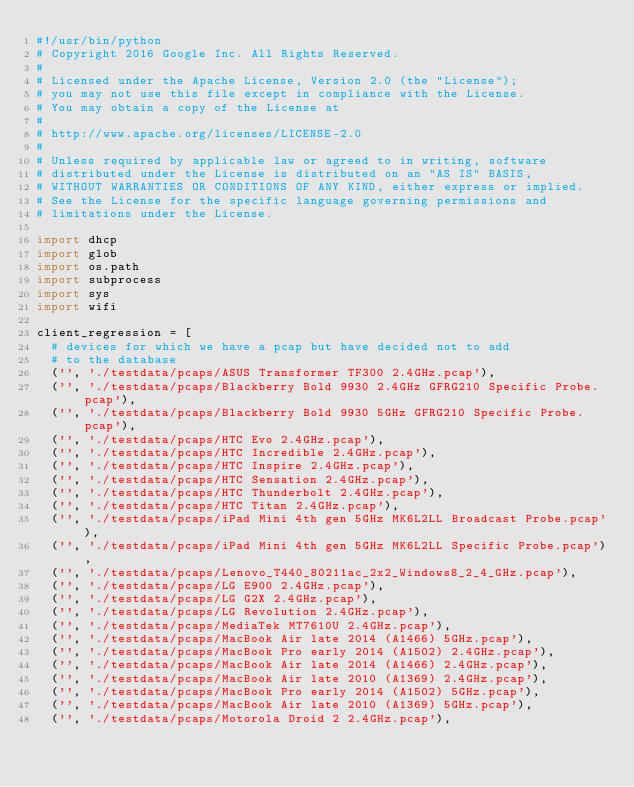<code> <loc_0><loc_0><loc_500><loc_500><_Python_>#!/usr/bin/python
# Copyright 2016 Google Inc. All Rights Reserved.
#
# Licensed under the Apache License, Version 2.0 (the "License");
# you may not use this file except in compliance with the License.
# You may obtain a copy of the License at
#
# http://www.apache.org/licenses/LICENSE-2.0
#
# Unless required by applicable law or agreed to in writing, software
# distributed under the License is distributed on an "AS IS" BASIS,
# WITHOUT WARRANTIES OR CONDITIONS OF ANY KIND, either express or implied.
# See the License for the specific language governing permissions and
# limitations under the License.

import dhcp
import glob
import os.path
import subprocess
import sys
import wifi

client_regression = [
  # devices for which we have a pcap but have decided not to add
  # to the database
  ('', './testdata/pcaps/ASUS Transformer TF300 2.4GHz.pcap'),
  ('', './testdata/pcaps/Blackberry Bold 9930 2.4GHz GFRG210 Specific Probe.pcap'),
  ('', './testdata/pcaps/Blackberry Bold 9930 5GHz GFRG210 Specific Probe.pcap'),
  ('', './testdata/pcaps/HTC Evo 2.4GHz.pcap'),
  ('', './testdata/pcaps/HTC Incredible 2.4GHz.pcap'),
  ('', './testdata/pcaps/HTC Inspire 2.4GHz.pcap'),
  ('', './testdata/pcaps/HTC Sensation 2.4GHz.pcap'),
  ('', './testdata/pcaps/HTC Thunderbolt 2.4GHz.pcap'),
  ('', './testdata/pcaps/HTC Titan 2.4GHz.pcap'),
  ('', './testdata/pcaps/iPad Mini 4th gen 5GHz MK6L2LL Broadcast Probe.pcap'),
  ('', './testdata/pcaps/iPad Mini 4th gen 5GHz MK6L2LL Specific Probe.pcap'),
  ('', './testdata/pcaps/Lenovo_T440_80211ac_2x2_Windows8_2_4_GHz.pcap'),
  ('', './testdata/pcaps/LG E900 2.4GHz.pcap'),
  ('', './testdata/pcaps/LG G2X 2.4GHz.pcap'),
  ('', './testdata/pcaps/LG Revolution 2.4GHz.pcap'),
  ('', './testdata/pcaps/MediaTek MT7610U 2.4GHz.pcap'),
  ('', './testdata/pcaps/MacBook Air late 2014 (A1466) 5GHz.pcap'),
  ('', './testdata/pcaps/MacBook Pro early 2014 (A1502) 2.4GHz.pcap'),
  ('', './testdata/pcaps/MacBook Air late 2014 (A1466) 2.4GHz.pcap'),
  ('', './testdata/pcaps/MacBook Air late 2010 (A1369) 2.4GHz.pcap'),
  ('', './testdata/pcaps/MacBook Pro early 2014 (A1502) 5GHz.pcap'),
  ('', './testdata/pcaps/MacBook Air late 2010 (A1369) 5GHz.pcap'),
  ('', './testdata/pcaps/Motorola Droid 2 2.4GHz.pcap'),</code> 